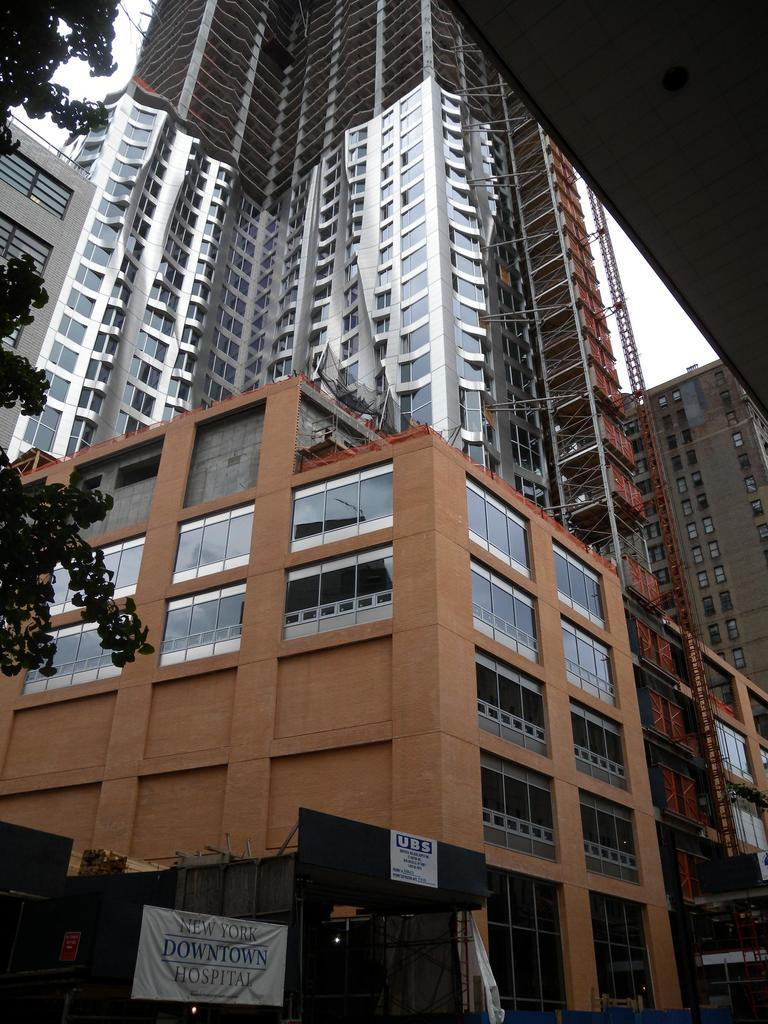What type of structures can be seen in the image? There are buildings in the image. What type of plant is present in the image? There is a tree in the image. What additional decorative elements can be seen in the image? There are banners in the image. What hobbies does the baby in the image enjoy? There is no baby present in the image, so we cannot determine any hobbies. 